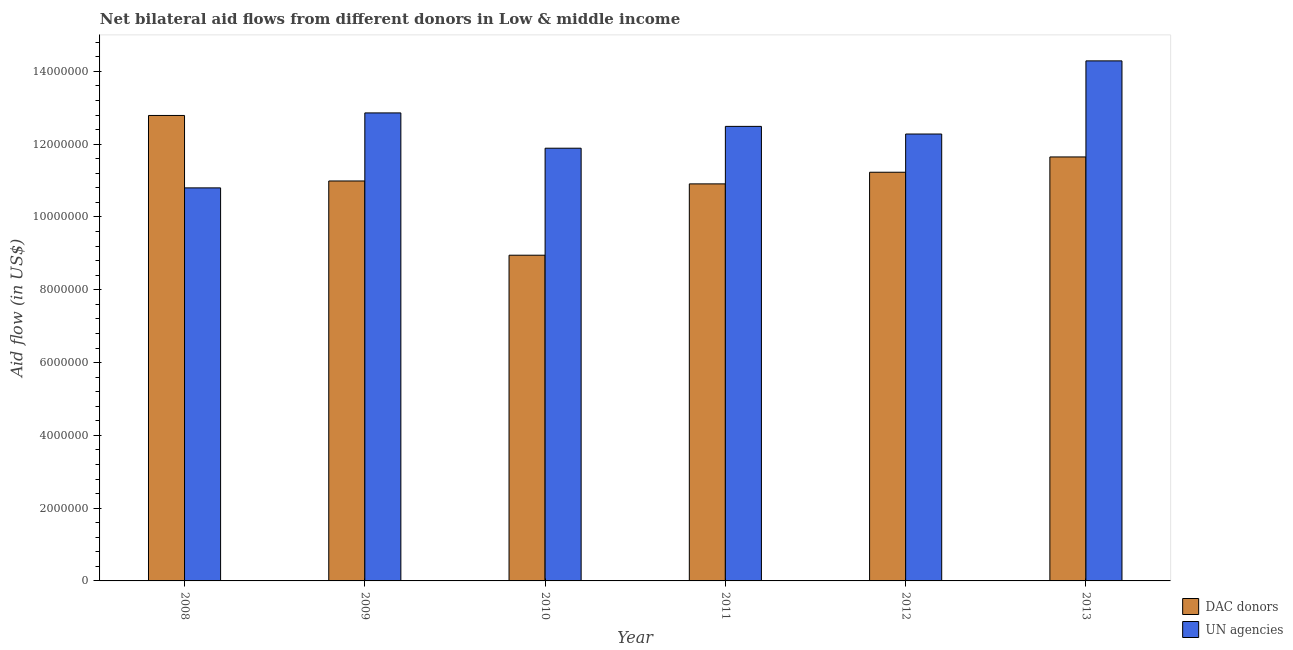How many different coloured bars are there?
Provide a short and direct response. 2. Are the number of bars per tick equal to the number of legend labels?
Ensure brevity in your answer.  Yes. How many bars are there on the 6th tick from the right?
Your answer should be compact. 2. What is the label of the 3rd group of bars from the left?
Your response must be concise. 2010. In how many cases, is the number of bars for a given year not equal to the number of legend labels?
Give a very brief answer. 0. What is the aid flow from dac donors in 2013?
Keep it short and to the point. 1.16e+07. Across all years, what is the maximum aid flow from dac donors?
Offer a very short reply. 1.28e+07. Across all years, what is the minimum aid flow from dac donors?
Give a very brief answer. 8.95e+06. In which year was the aid flow from dac donors maximum?
Your answer should be compact. 2008. What is the total aid flow from un agencies in the graph?
Provide a short and direct response. 7.46e+07. What is the difference between the aid flow from un agencies in 2012 and that in 2013?
Make the answer very short. -2.01e+06. What is the difference between the aid flow from un agencies in 2008 and the aid flow from dac donors in 2009?
Your response must be concise. -2.06e+06. What is the average aid flow from dac donors per year?
Your answer should be compact. 1.11e+07. What is the ratio of the aid flow from un agencies in 2008 to that in 2011?
Offer a terse response. 0.86. Is the aid flow from un agencies in 2010 less than that in 2012?
Your answer should be compact. Yes. What is the difference between the highest and the second highest aid flow from un agencies?
Provide a short and direct response. 1.43e+06. What is the difference between the highest and the lowest aid flow from un agencies?
Provide a succinct answer. 3.49e+06. Is the sum of the aid flow from dac donors in 2009 and 2013 greater than the maximum aid flow from un agencies across all years?
Give a very brief answer. Yes. What does the 1st bar from the left in 2011 represents?
Offer a very short reply. DAC donors. What does the 2nd bar from the right in 2012 represents?
Offer a terse response. DAC donors. Are all the bars in the graph horizontal?
Your response must be concise. No. Are the values on the major ticks of Y-axis written in scientific E-notation?
Provide a short and direct response. No. How are the legend labels stacked?
Give a very brief answer. Vertical. What is the title of the graph?
Give a very brief answer. Net bilateral aid flows from different donors in Low & middle income. Does "Infant" appear as one of the legend labels in the graph?
Offer a terse response. No. What is the label or title of the Y-axis?
Ensure brevity in your answer.  Aid flow (in US$). What is the Aid flow (in US$) in DAC donors in 2008?
Your response must be concise. 1.28e+07. What is the Aid flow (in US$) in UN agencies in 2008?
Provide a succinct answer. 1.08e+07. What is the Aid flow (in US$) in DAC donors in 2009?
Offer a very short reply. 1.10e+07. What is the Aid flow (in US$) in UN agencies in 2009?
Offer a terse response. 1.29e+07. What is the Aid flow (in US$) of DAC donors in 2010?
Your answer should be very brief. 8.95e+06. What is the Aid flow (in US$) of UN agencies in 2010?
Make the answer very short. 1.19e+07. What is the Aid flow (in US$) in DAC donors in 2011?
Give a very brief answer. 1.09e+07. What is the Aid flow (in US$) of UN agencies in 2011?
Offer a very short reply. 1.25e+07. What is the Aid flow (in US$) of DAC donors in 2012?
Keep it short and to the point. 1.12e+07. What is the Aid flow (in US$) in UN agencies in 2012?
Offer a very short reply. 1.23e+07. What is the Aid flow (in US$) of DAC donors in 2013?
Your answer should be very brief. 1.16e+07. What is the Aid flow (in US$) of UN agencies in 2013?
Your response must be concise. 1.43e+07. Across all years, what is the maximum Aid flow (in US$) of DAC donors?
Make the answer very short. 1.28e+07. Across all years, what is the maximum Aid flow (in US$) of UN agencies?
Provide a succinct answer. 1.43e+07. Across all years, what is the minimum Aid flow (in US$) of DAC donors?
Offer a very short reply. 8.95e+06. Across all years, what is the minimum Aid flow (in US$) of UN agencies?
Ensure brevity in your answer.  1.08e+07. What is the total Aid flow (in US$) in DAC donors in the graph?
Offer a terse response. 6.65e+07. What is the total Aid flow (in US$) of UN agencies in the graph?
Offer a terse response. 7.46e+07. What is the difference between the Aid flow (in US$) of DAC donors in 2008 and that in 2009?
Offer a terse response. 1.80e+06. What is the difference between the Aid flow (in US$) in UN agencies in 2008 and that in 2009?
Keep it short and to the point. -2.06e+06. What is the difference between the Aid flow (in US$) of DAC donors in 2008 and that in 2010?
Give a very brief answer. 3.84e+06. What is the difference between the Aid flow (in US$) in UN agencies in 2008 and that in 2010?
Provide a succinct answer. -1.09e+06. What is the difference between the Aid flow (in US$) in DAC donors in 2008 and that in 2011?
Make the answer very short. 1.88e+06. What is the difference between the Aid flow (in US$) in UN agencies in 2008 and that in 2011?
Provide a short and direct response. -1.69e+06. What is the difference between the Aid flow (in US$) in DAC donors in 2008 and that in 2012?
Give a very brief answer. 1.56e+06. What is the difference between the Aid flow (in US$) of UN agencies in 2008 and that in 2012?
Your response must be concise. -1.48e+06. What is the difference between the Aid flow (in US$) of DAC donors in 2008 and that in 2013?
Give a very brief answer. 1.14e+06. What is the difference between the Aid flow (in US$) of UN agencies in 2008 and that in 2013?
Provide a succinct answer. -3.49e+06. What is the difference between the Aid flow (in US$) of DAC donors in 2009 and that in 2010?
Keep it short and to the point. 2.04e+06. What is the difference between the Aid flow (in US$) in UN agencies in 2009 and that in 2010?
Offer a terse response. 9.70e+05. What is the difference between the Aid flow (in US$) in DAC donors in 2009 and that in 2011?
Provide a short and direct response. 8.00e+04. What is the difference between the Aid flow (in US$) in UN agencies in 2009 and that in 2011?
Keep it short and to the point. 3.70e+05. What is the difference between the Aid flow (in US$) in UN agencies in 2009 and that in 2012?
Your response must be concise. 5.80e+05. What is the difference between the Aid flow (in US$) of DAC donors in 2009 and that in 2013?
Offer a terse response. -6.60e+05. What is the difference between the Aid flow (in US$) in UN agencies in 2009 and that in 2013?
Keep it short and to the point. -1.43e+06. What is the difference between the Aid flow (in US$) in DAC donors in 2010 and that in 2011?
Your answer should be compact. -1.96e+06. What is the difference between the Aid flow (in US$) of UN agencies in 2010 and that in 2011?
Give a very brief answer. -6.00e+05. What is the difference between the Aid flow (in US$) of DAC donors in 2010 and that in 2012?
Your answer should be compact. -2.28e+06. What is the difference between the Aid flow (in US$) of UN agencies in 2010 and that in 2012?
Your answer should be very brief. -3.90e+05. What is the difference between the Aid flow (in US$) in DAC donors in 2010 and that in 2013?
Your answer should be compact. -2.70e+06. What is the difference between the Aid flow (in US$) of UN agencies in 2010 and that in 2013?
Your answer should be very brief. -2.40e+06. What is the difference between the Aid flow (in US$) in DAC donors in 2011 and that in 2012?
Offer a terse response. -3.20e+05. What is the difference between the Aid flow (in US$) in DAC donors in 2011 and that in 2013?
Provide a short and direct response. -7.40e+05. What is the difference between the Aid flow (in US$) in UN agencies in 2011 and that in 2013?
Provide a succinct answer. -1.80e+06. What is the difference between the Aid flow (in US$) in DAC donors in 2012 and that in 2013?
Offer a very short reply. -4.20e+05. What is the difference between the Aid flow (in US$) of UN agencies in 2012 and that in 2013?
Make the answer very short. -2.01e+06. What is the difference between the Aid flow (in US$) in DAC donors in 2008 and the Aid flow (in US$) in UN agencies in 2010?
Offer a very short reply. 9.00e+05. What is the difference between the Aid flow (in US$) in DAC donors in 2008 and the Aid flow (in US$) in UN agencies in 2012?
Keep it short and to the point. 5.10e+05. What is the difference between the Aid flow (in US$) in DAC donors in 2008 and the Aid flow (in US$) in UN agencies in 2013?
Offer a very short reply. -1.50e+06. What is the difference between the Aid flow (in US$) in DAC donors in 2009 and the Aid flow (in US$) in UN agencies in 2010?
Your answer should be compact. -9.00e+05. What is the difference between the Aid flow (in US$) in DAC donors in 2009 and the Aid flow (in US$) in UN agencies in 2011?
Offer a terse response. -1.50e+06. What is the difference between the Aid flow (in US$) in DAC donors in 2009 and the Aid flow (in US$) in UN agencies in 2012?
Give a very brief answer. -1.29e+06. What is the difference between the Aid flow (in US$) in DAC donors in 2009 and the Aid flow (in US$) in UN agencies in 2013?
Keep it short and to the point. -3.30e+06. What is the difference between the Aid flow (in US$) of DAC donors in 2010 and the Aid flow (in US$) of UN agencies in 2011?
Your answer should be very brief. -3.54e+06. What is the difference between the Aid flow (in US$) of DAC donors in 2010 and the Aid flow (in US$) of UN agencies in 2012?
Ensure brevity in your answer.  -3.33e+06. What is the difference between the Aid flow (in US$) of DAC donors in 2010 and the Aid flow (in US$) of UN agencies in 2013?
Offer a very short reply. -5.34e+06. What is the difference between the Aid flow (in US$) of DAC donors in 2011 and the Aid flow (in US$) of UN agencies in 2012?
Give a very brief answer. -1.37e+06. What is the difference between the Aid flow (in US$) in DAC donors in 2011 and the Aid flow (in US$) in UN agencies in 2013?
Provide a short and direct response. -3.38e+06. What is the difference between the Aid flow (in US$) of DAC donors in 2012 and the Aid flow (in US$) of UN agencies in 2013?
Offer a very short reply. -3.06e+06. What is the average Aid flow (in US$) of DAC donors per year?
Give a very brief answer. 1.11e+07. What is the average Aid flow (in US$) of UN agencies per year?
Provide a short and direct response. 1.24e+07. In the year 2008, what is the difference between the Aid flow (in US$) of DAC donors and Aid flow (in US$) of UN agencies?
Provide a short and direct response. 1.99e+06. In the year 2009, what is the difference between the Aid flow (in US$) of DAC donors and Aid flow (in US$) of UN agencies?
Make the answer very short. -1.87e+06. In the year 2010, what is the difference between the Aid flow (in US$) of DAC donors and Aid flow (in US$) of UN agencies?
Ensure brevity in your answer.  -2.94e+06. In the year 2011, what is the difference between the Aid flow (in US$) of DAC donors and Aid flow (in US$) of UN agencies?
Make the answer very short. -1.58e+06. In the year 2012, what is the difference between the Aid flow (in US$) of DAC donors and Aid flow (in US$) of UN agencies?
Keep it short and to the point. -1.05e+06. In the year 2013, what is the difference between the Aid flow (in US$) of DAC donors and Aid flow (in US$) of UN agencies?
Your answer should be very brief. -2.64e+06. What is the ratio of the Aid flow (in US$) in DAC donors in 2008 to that in 2009?
Provide a short and direct response. 1.16. What is the ratio of the Aid flow (in US$) of UN agencies in 2008 to that in 2009?
Your answer should be very brief. 0.84. What is the ratio of the Aid flow (in US$) of DAC donors in 2008 to that in 2010?
Offer a terse response. 1.43. What is the ratio of the Aid flow (in US$) in UN agencies in 2008 to that in 2010?
Your response must be concise. 0.91. What is the ratio of the Aid flow (in US$) in DAC donors in 2008 to that in 2011?
Provide a succinct answer. 1.17. What is the ratio of the Aid flow (in US$) of UN agencies in 2008 to that in 2011?
Keep it short and to the point. 0.86. What is the ratio of the Aid flow (in US$) of DAC donors in 2008 to that in 2012?
Offer a terse response. 1.14. What is the ratio of the Aid flow (in US$) of UN agencies in 2008 to that in 2012?
Offer a very short reply. 0.88. What is the ratio of the Aid flow (in US$) in DAC donors in 2008 to that in 2013?
Provide a succinct answer. 1.1. What is the ratio of the Aid flow (in US$) of UN agencies in 2008 to that in 2013?
Your answer should be compact. 0.76. What is the ratio of the Aid flow (in US$) in DAC donors in 2009 to that in 2010?
Provide a short and direct response. 1.23. What is the ratio of the Aid flow (in US$) of UN agencies in 2009 to that in 2010?
Your answer should be compact. 1.08. What is the ratio of the Aid flow (in US$) in DAC donors in 2009 to that in 2011?
Your answer should be compact. 1.01. What is the ratio of the Aid flow (in US$) of UN agencies in 2009 to that in 2011?
Ensure brevity in your answer.  1.03. What is the ratio of the Aid flow (in US$) in DAC donors in 2009 to that in 2012?
Your answer should be very brief. 0.98. What is the ratio of the Aid flow (in US$) in UN agencies in 2009 to that in 2012?
Offer a very short reply. 1.05. What is the ratio of the Aid flow (in US$) in DAC donors in 2009 to that in 2013?
Provide a succinct answer. 0.94. What is the ratio of the Aid flow (in US$) of UN agencies in 2009 to that in 2013?
Your answer should be compact. 0.9. What is the ratio of the Aid flow (in US$) in DAC donors in 2010 to that in 2011?
Your response must be concise. 0.82. What is the ratio of the Aid flow (in US$) of UN agencies in 2010 to that in 2011?
Offer a terse response. 0.95. What is the ratio of the Aid flow (in US$) of DAC donors in 2010 to that in 2012?
Provide a short and direct response. 0.8. What is the ratio of the Aid flow (in US$) of UN agencies in 2010 to that in 2012?
Offer a very short reply. 0.97. What is the ratio of the Aid flow (in US$) of DAC donors in 2010 to that in 2013?
Offer a very short reply. 0.77. What is the ratio of the Aid flow (in US$) of UN agencies in 2010 to that in 2013?
Provide a short and direct response. 0.83. What is the ratio of the Aid flow (in US$) of DAC donors in 2011 to that in 2012?
Offer a very short reply. 0.97. What is the ratio of the Aid flow (in US$) of UN agencies in 2011 to that in 2012?
Keep it short and to the point. 1.02. What is the ratio of the Aid flow (in US$) of DAC donors in 2011 to that in 2013?
Ensure brevity in your answer.  0.94. What is the ratio of the Aid flow (in US$) of UN agencies in 2011 to that in 2013?
Give a very brief answer. 0.87. What is the ratio of the Aid flow (in US$) of DAC donors in 2012 to that in 2013?
Provide a short and direct response. 0.96. What is the ratio of the Aid flow (in US$) in UN agencies in 2012 to that in 2013?
Offer a terse response. 0.86. What is the difference between the highest and the second highest Aid flow (in US$) in DAC donors?
Provide a succinct answer. 1.14e+06. What is the difference between the highest and the second highest Aid flow (in US$) of UN agencies?
Keep it short and to the point. 1.43e+06. What is the difference between the highest and the lowest Aid flow (in US$) of DAC donors?
Your answer should be very brief. 3.84e+06. What is the difference between the highest and the lowest Aid flow (in US$) in UN agencies?
Provide a short and direct response. 3.49e+06. 